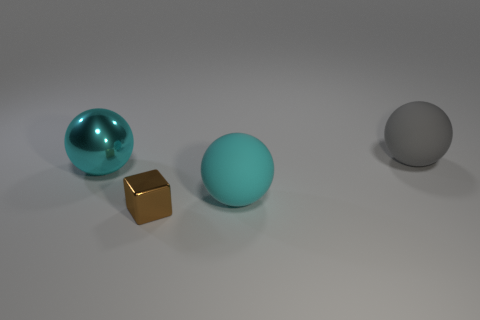There is a big ball that is made of the same material as the block; what is its color?
Make the answer very short. Cyan. Is the size of the metal cube the same as the matte sphere to the left of the large gray sphere?
Ensure brevity in your answer.  No. The tiny thing has what shape?
Your answer should be very brief. Cube. How many metal things are the same color as the tiny cube?
Your answer should be very brief. 0. There is another matte object that is the same shape as the large cyan matte object; what is its color?
Your answer should be very brief. Gray. What number of brown metal things are behind the big rubber thing in front of the gray sphere?
Your response must be concise. 0. What number of cubes are small things or brown matte objects?
Provide a short and direct response. 1. Are there any cyan balls?
Provide a short and direct response. Yes. The matte object in front of the large matte ball that is behind the shiny sphere is what shape?
Provide a short and direct response. Sphere. What number of cyan things are blocks or rubber things?
Offer a terse response. 1. 